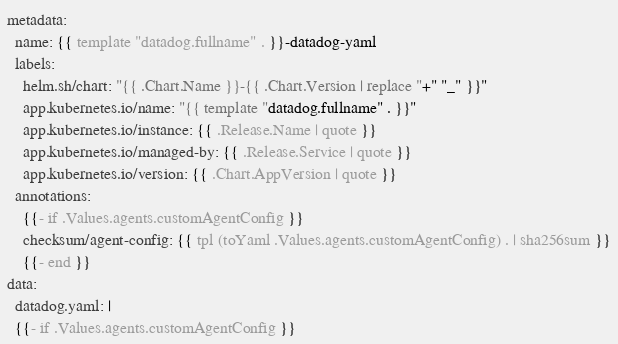Convert code to text. <code><loc_0><loc_0><loc_500><loc_500><_YAML_>metadata:
  name: {{ template "datadog.fullname" . }}-datadog-yaml
  labels:
    helm.sh/chart: "{{ .Chart.Name }}-{{ .Chart.Version | replace "+" "_" }}"
    app.kubernetes.io/name: "{{ template "datadog.fullname" . }}"
    app.kubernetes.io/instance: {{ .Release.Name | quote }}
    app.kubernetes.io/managed-by: {{ .Release.Service | quote }}
    app.kubernetes.io/version: {{ .Chart.AppVersion | quote }}
  annotations:
    {{- if .Values.agents.customAgentConfig }}
    checksum/agent-config: {{ tpl (toYaml .Values.agents.customAgentConfig) . | sha256sum }}
    {{- end }}
data:
  datadog.yaml: |
  {{- if .Values.agents.customAgentConfig }}</code> 